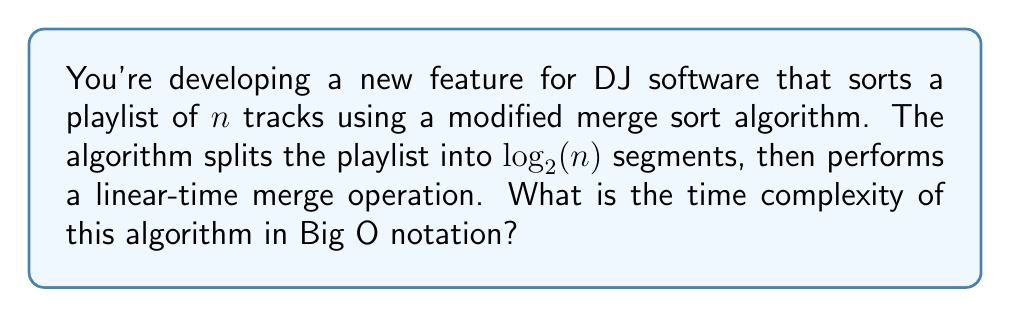Teach me how to tackle this problem. Let's break this down step-by-step:

1) First, we need to understand the structure of the algorithm:
   - It splits the playlist into $\log_2(n)$ segments
   - Then it performs a linear-time merge operation

2) The splitting operation:
   - Splitting into $\log_2(n)$ segments takes $O(\log n)$ time

3) The merging operation:
   - A linear-time merge operation takes $O(n)$ time

4) Combining the operations:
   - We're performing an $O(n)$ operation $\log_2(n)$ times
   - This can be expressed as $O(n \log n)$

5) Simplifying:
   - In Big O notation, we don't specify the base of the logarithm
   - So we can simplify $O(n \log_2 n)$ to $O(n \log n)$

Therefore, the time complexity of this algorithm is $O(n \log n)$.
Answer: $O(n \log n)$ 